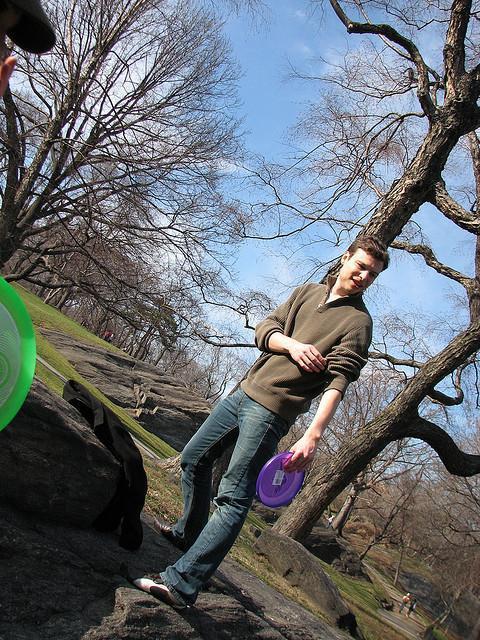How many frisbees can be seen?
Give a very brief answer. 1. 